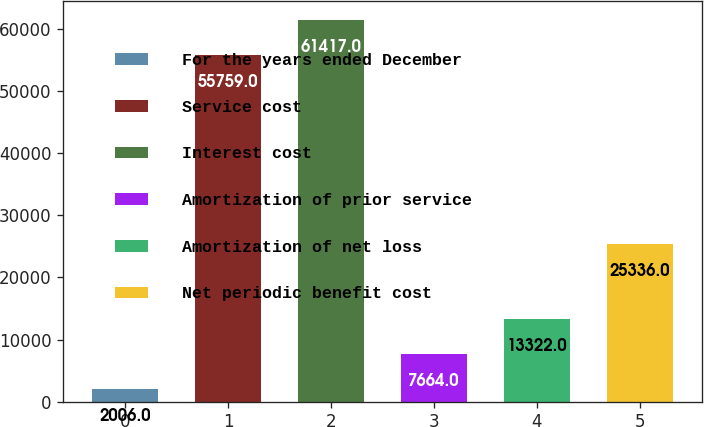<chart> <loc_0><loc_0><loc_500><loc_500><bar_chart><fcel>For the years ended December<fcel>Service cost<fcel>Interest cost<fcel>Amortization of prior service<fcel>Amortization of net loss<fcel>Net periodic benefit cost<nl><fcel>2006<fcel>55759<fcel>61417<fcel>7664<fcel>13322<fcel>25336<nl></chart> 